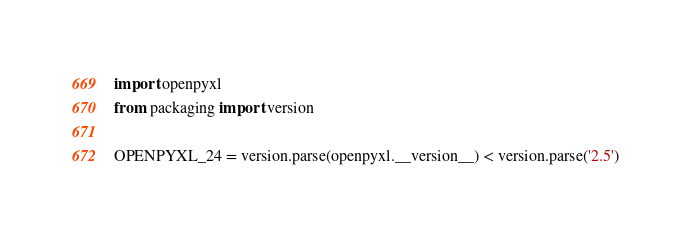<code> <loc_0><loc_0><loc_500><loc_500><_Python_>import openpyxl
from packaging import version

OPENPYXL_24 = version.parse(openpyxl.__version__) < version.parse('2.5')
</code> 